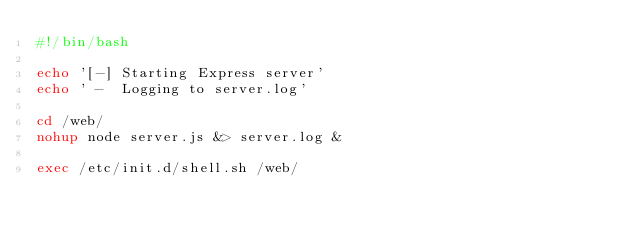<code> <loc_0><loc_0><loc_500><loc_500><_Bash_>#!/bin/bash

echo '[-] Starting Express server'
echo ' -  Logging to server.log'

cd /web/
nohup node server.js &> server.log &

exec /etc/init.d/shell.sh /web/
</code> 